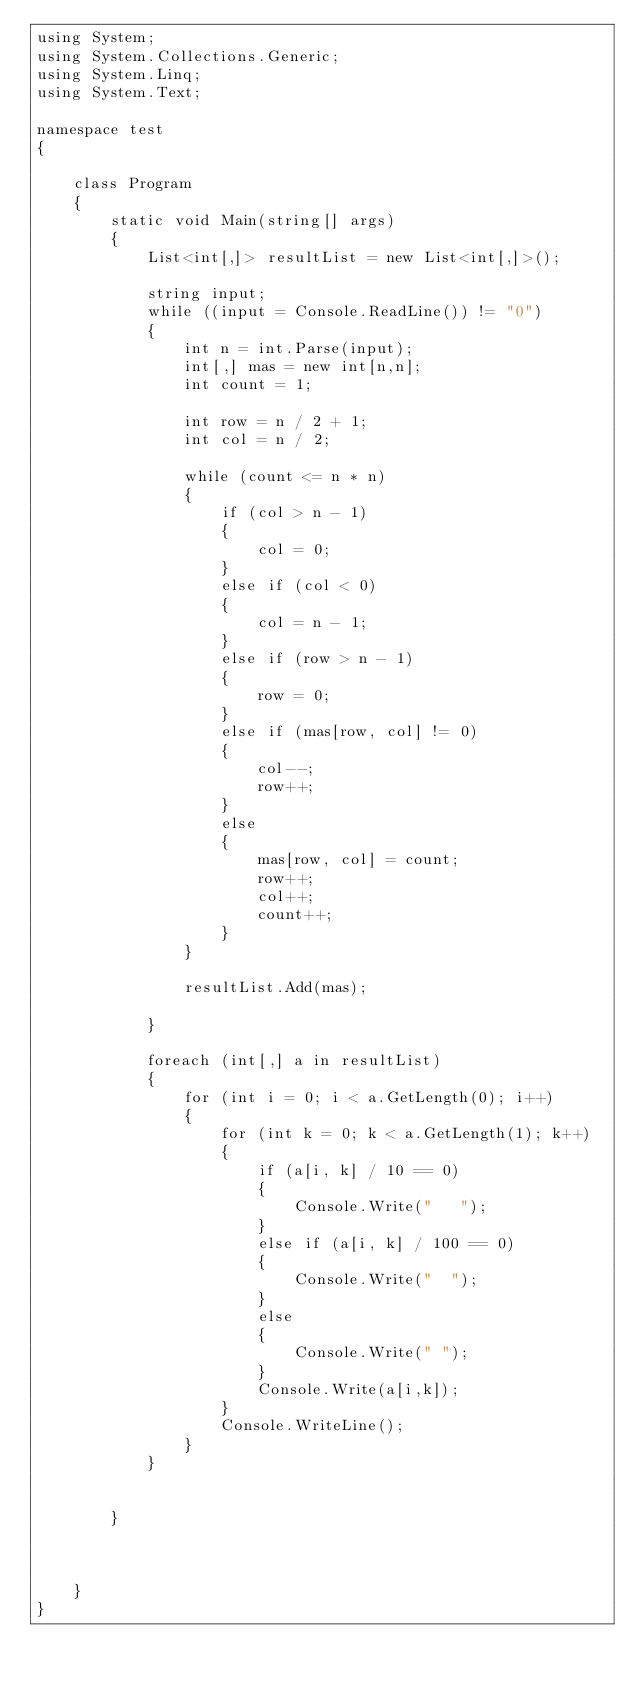Convert code to text. <code><loc_0><loc_0><loc_500><loc_500><_C#_>using System;
using System.Collections.Generic;
using System.Linq;
using System.Text;

namespace test
{

    class Program
    {
        static void Main(string[] args)
        {
            List<int[,]> resultList = new List<int[,]>();

            string input;
            while ((input = Console.ReadLine()) != "0")
            {
                int n = int.Parse(input);
                int[,] mas = new int[n,n];
                int count = 1;

                int row = n / 2 + 1;
                int col = n / 2;

                while (count <= n * n)
                {
                    if (col > n - 1)
                    {
                        col = 0;
                    }
                    else if (col < 0)
                    {
                        col = n - 1;
                    }
                    else if (row > n - 1)
                    {
                        row = 0;
                    }
                    else if (mas[row, col] != 0)
                    {
                        col--;
                        row++;
                    }
                    else
                    {
                        mas[row, col] = count;
                        row++;
                        col++;
                        count++;
                    }
                }

                resultList.Add(mas);

            }

            foreach (int[,] a in resultList)
            {
                for (int i = 0; i < a.GetLength(0); i++)
                {
                    for (int k = 0; k < a.GetLength(1); k++)
                    {
                        if (a[i, k] / 10 == 0)
                        {
                            Console.Write("   ");
                        }
                        else if (a[i, k] / 100 == 0)
                        {
                            Console.Write("  ");
                        }
                        else
                        {
                            Console.Write(" ");
                        }
                        Console.Write(a[i,k]);
                    }
                    Console.WriteLine();
                }
            }


        }


        
    }
}</code> 